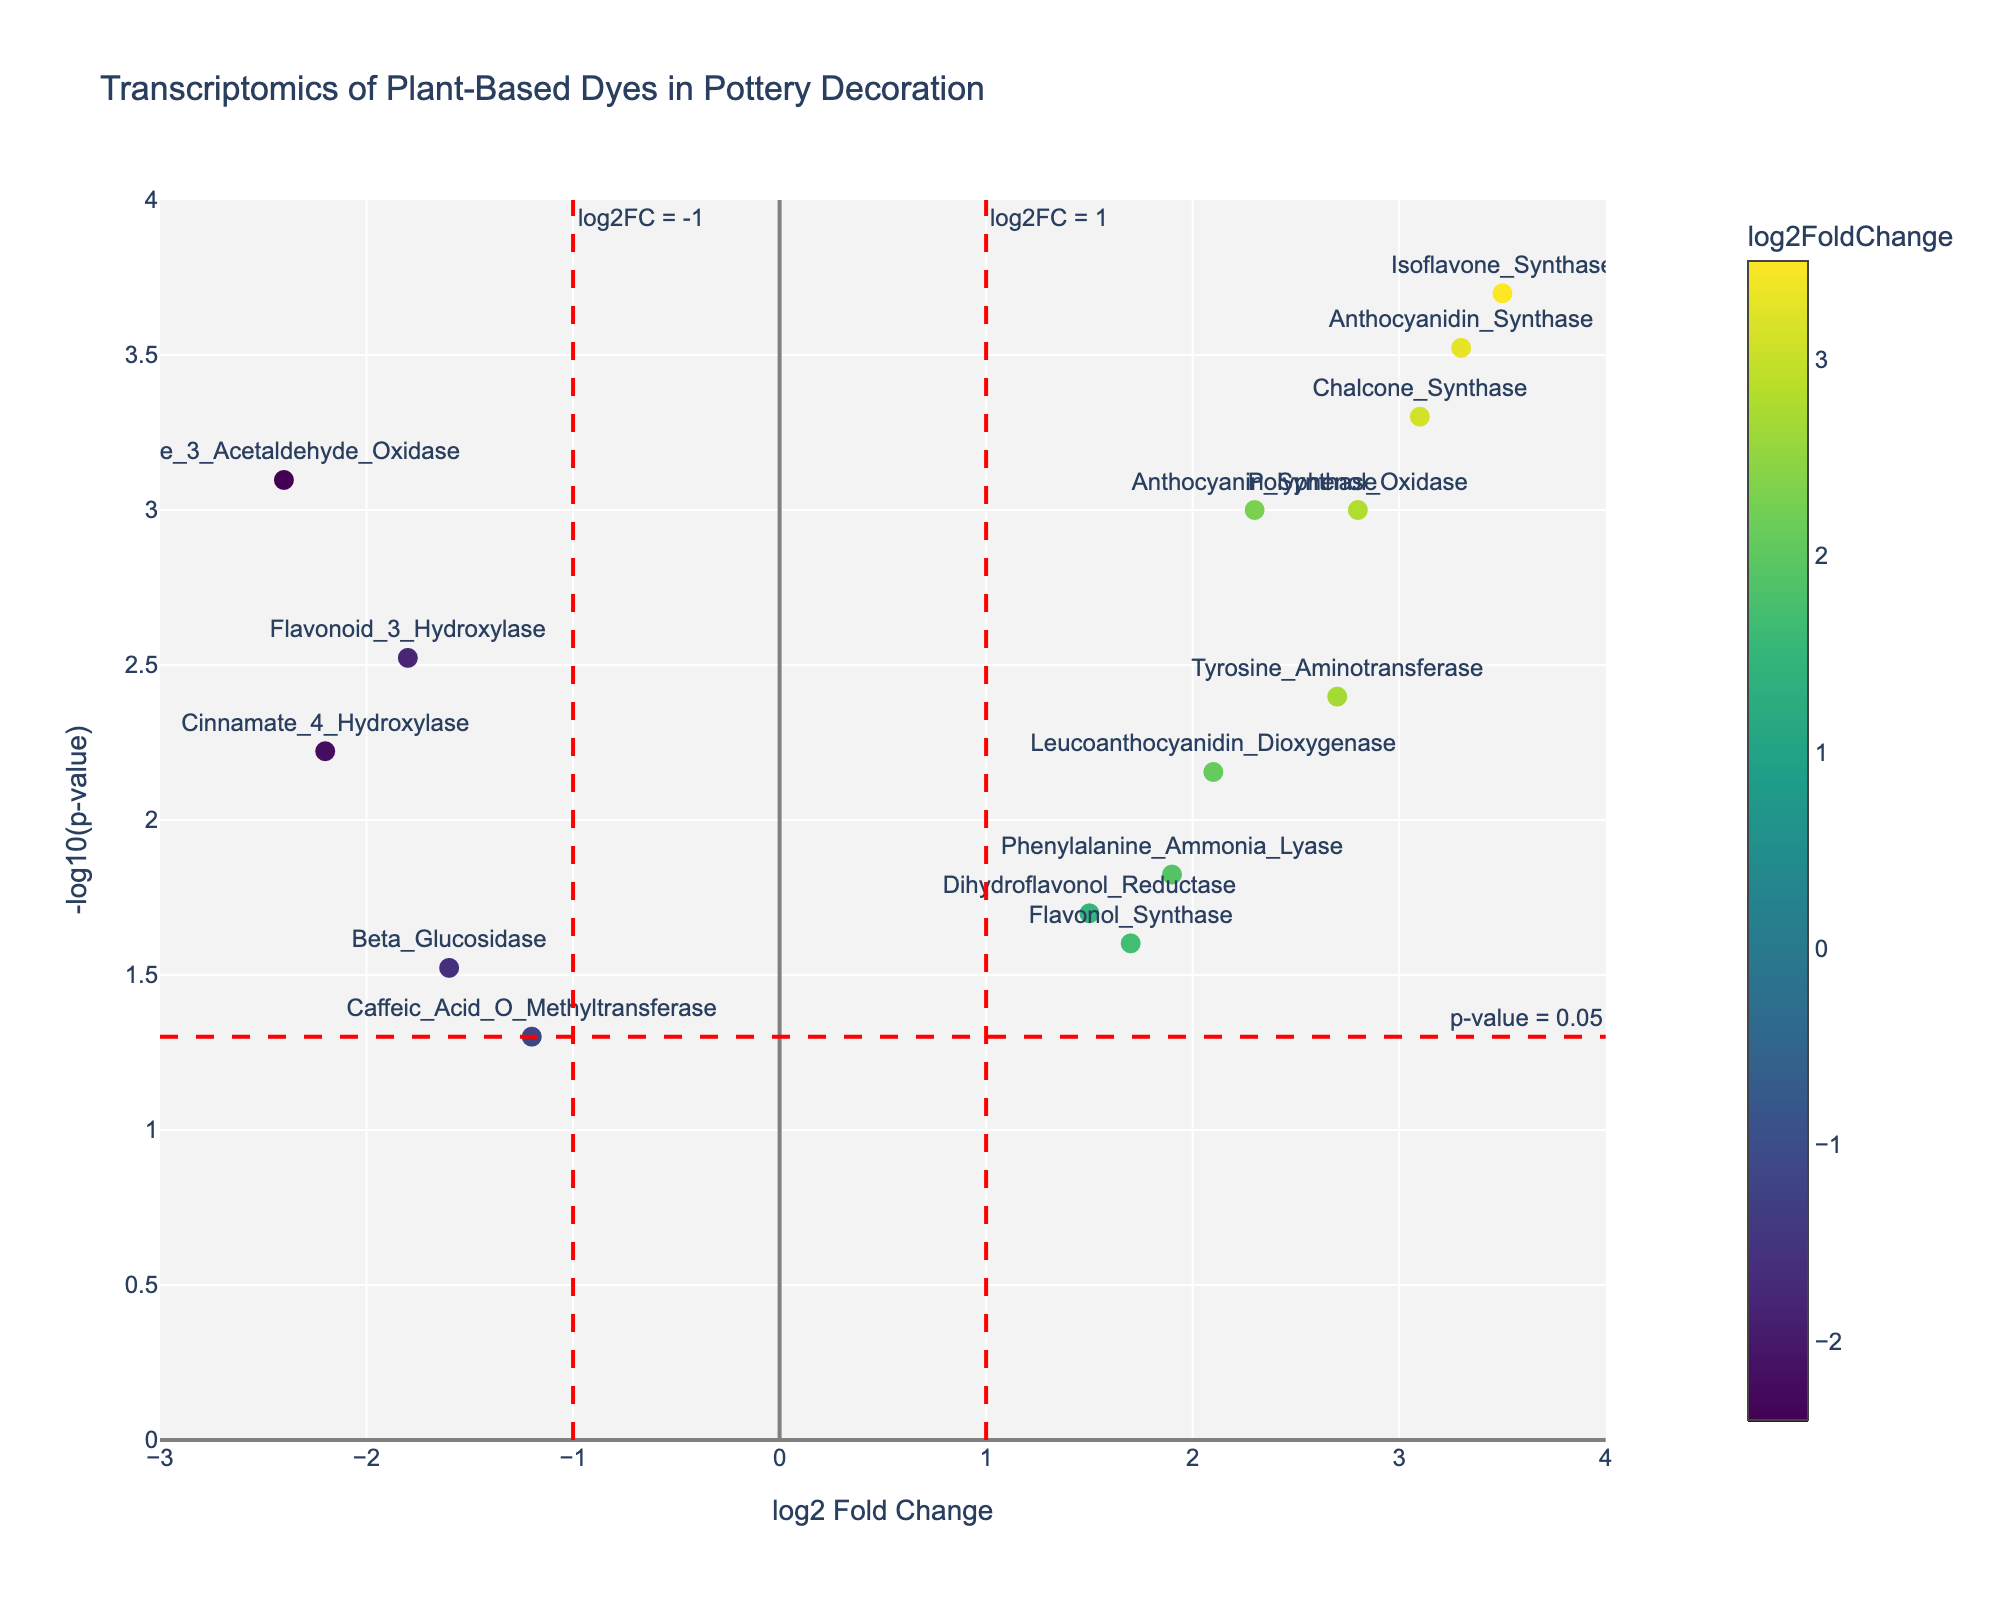How many genes are shown in the plot? Count all the individual data points on the plot. Each data point represents a unique gene.
Answer: 15 What is the log2 Fold Change (log2FC) for the gene with the most significant p-value? The most significant p-value is the smallest one, so look for the gene with the smallest p-value and then identify its log2FC value. Here, Isoflavone_Synthase has the smallest p-value (0.0002). Its log2FC is 3.5.
Answer: 3.5 Which gene has the highest log2 Fold Change (log2FC)? Compare the log2FC values of all the genes and identify the largest one. Isoflavone_Synthase has the highest log2FC of 3.5.
Answer: Isoflavone_Synthase How many genes have a p-value less than 0.05? Identify all the data points that have -log10(p-value) greater than -log10(0.05). This is because -log10(0.05) is used as a threshold in the plot, marked by the horizontal dashed red line. Count these points.
Answer: 13 Which genes have a negative log2 Fold Change? Identify and list all genes with their log2FC values less than 0. Flavonoid_3_Hydroxylase, Indole_3_Acetaldehyde_Oxidase, Caffeic_Acid_O_Methyltransferase, Beta_Glucosidase, and Cinnamate_4_Hydroxylase have negative log2FC values.
Answer: Flavonoid_3_Hydroxylase, Indole_3_Acetaldehyde_Oxidase, Caffeic_Acid_O_Methyltransferase, Beta_Glucosidase, Cinnamate_4_Hydroxylase Which gene has the highest -log10(p-value)? Find the gene with the maximum y-axis value (-log10(p-value)) in the plot. Isoflavone_Synthase has the highest -log10(p-value) of about 3.7, correlating to a p-value of 0.0002.
Answer: Isoflavone_Synthase What is the range of log2 Fold Change values in the plot? Identify the minimum and maximum log2FC values from the data provided. The minimum log2FC is -2.4 (Indole_3_Acetaldehyde_Oxidase), and the maximum is 3.5 (Isoflavone_Synthase). The range is calculated as the difference between the maximum and minimum values.
Answer: 5.9 Is any gene with a p-value equal to 0.05? Locate the red horizontal dashed line at -log10(p-value) equal to -log10(0.05) and check if any data points lie directly on this line. Caffeic_Acid_O_Methyltransferase lies directly on this threshold.
Answer: Caffeic_Acid_O_Methyltransferase 